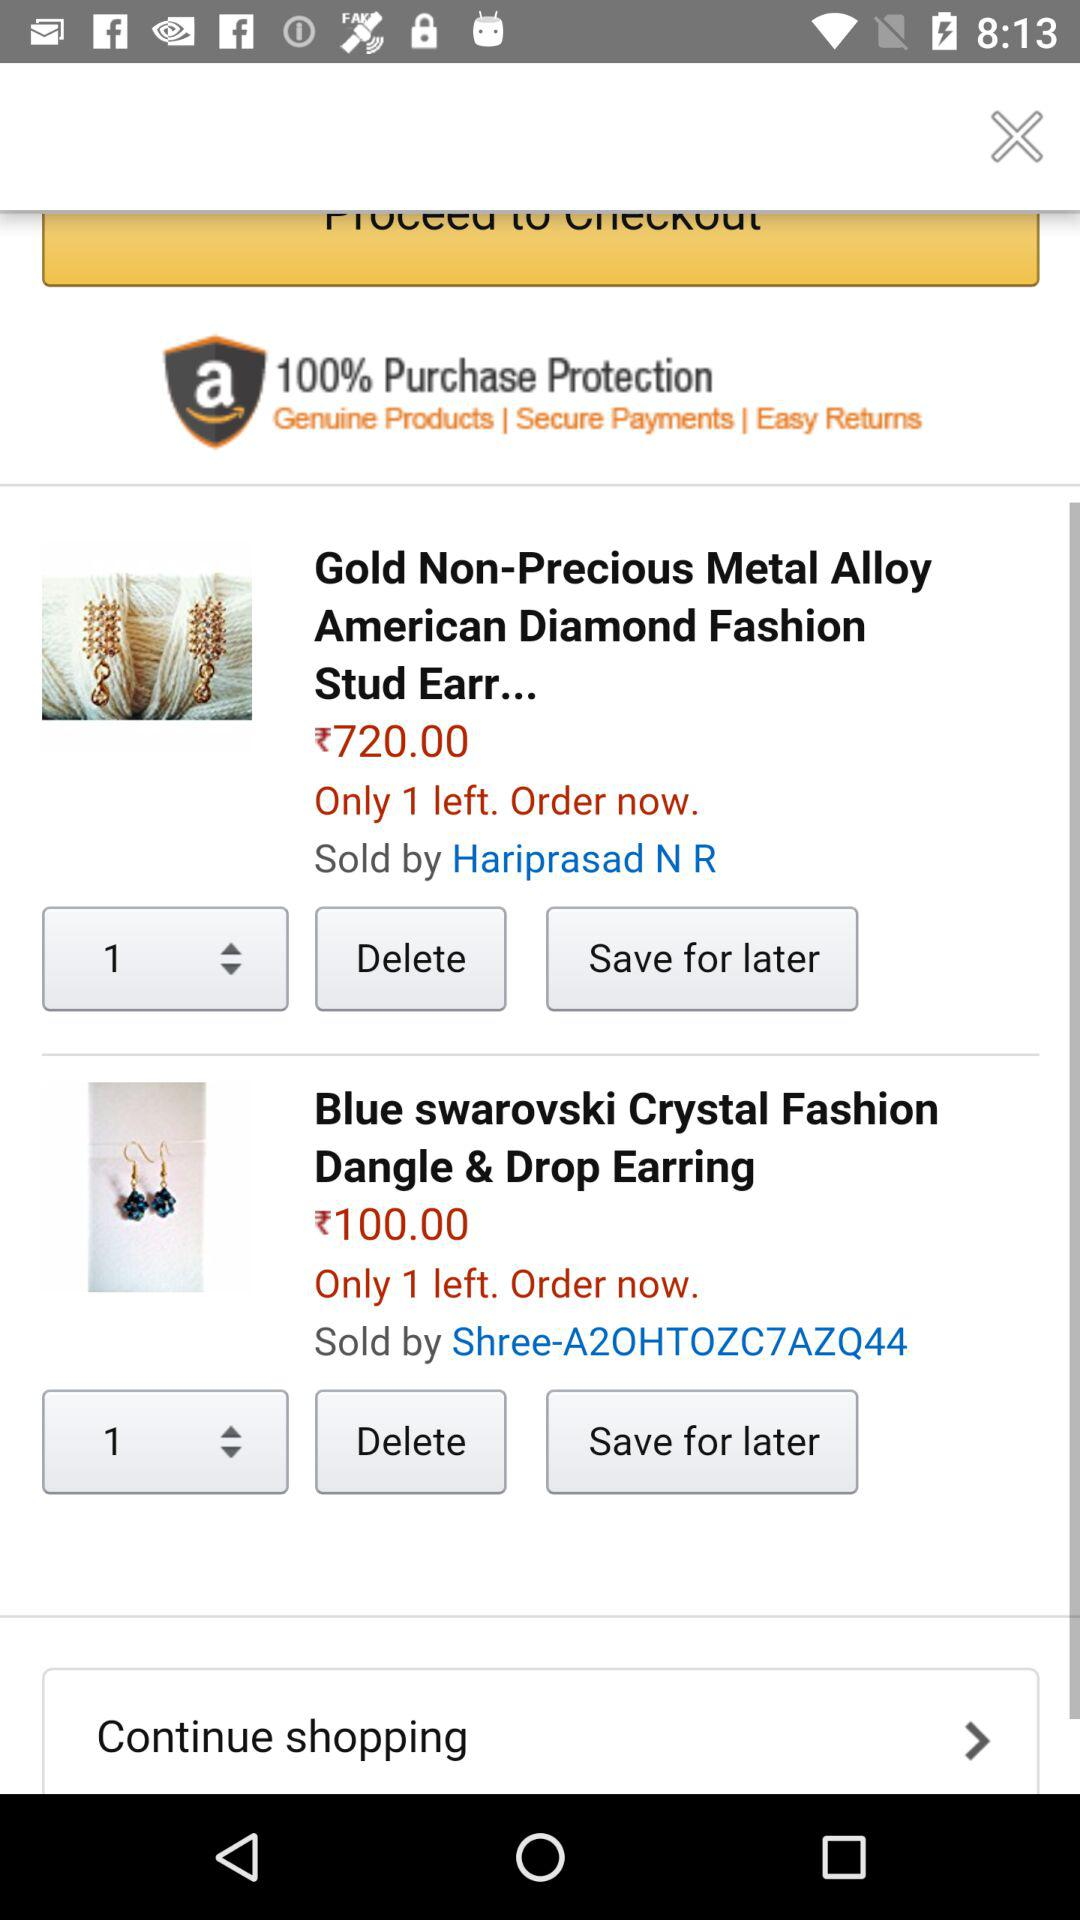Which company sells "Blue swarovski Crystal Fashion Dangle & Drop Earring"? The company that sells "Blue swarovski Crystal Fashion Dangle & Drop Earring" is "Shree-A20HTOZC7AZQ44". 